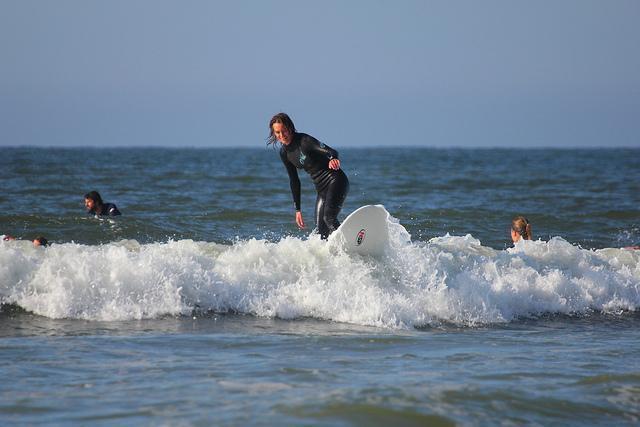How many persons are there?
Give a very brief answer. 4. How many people are shown?
Give a very brief answer. 4. How many People are there?
Give a very brief answer. 4. 